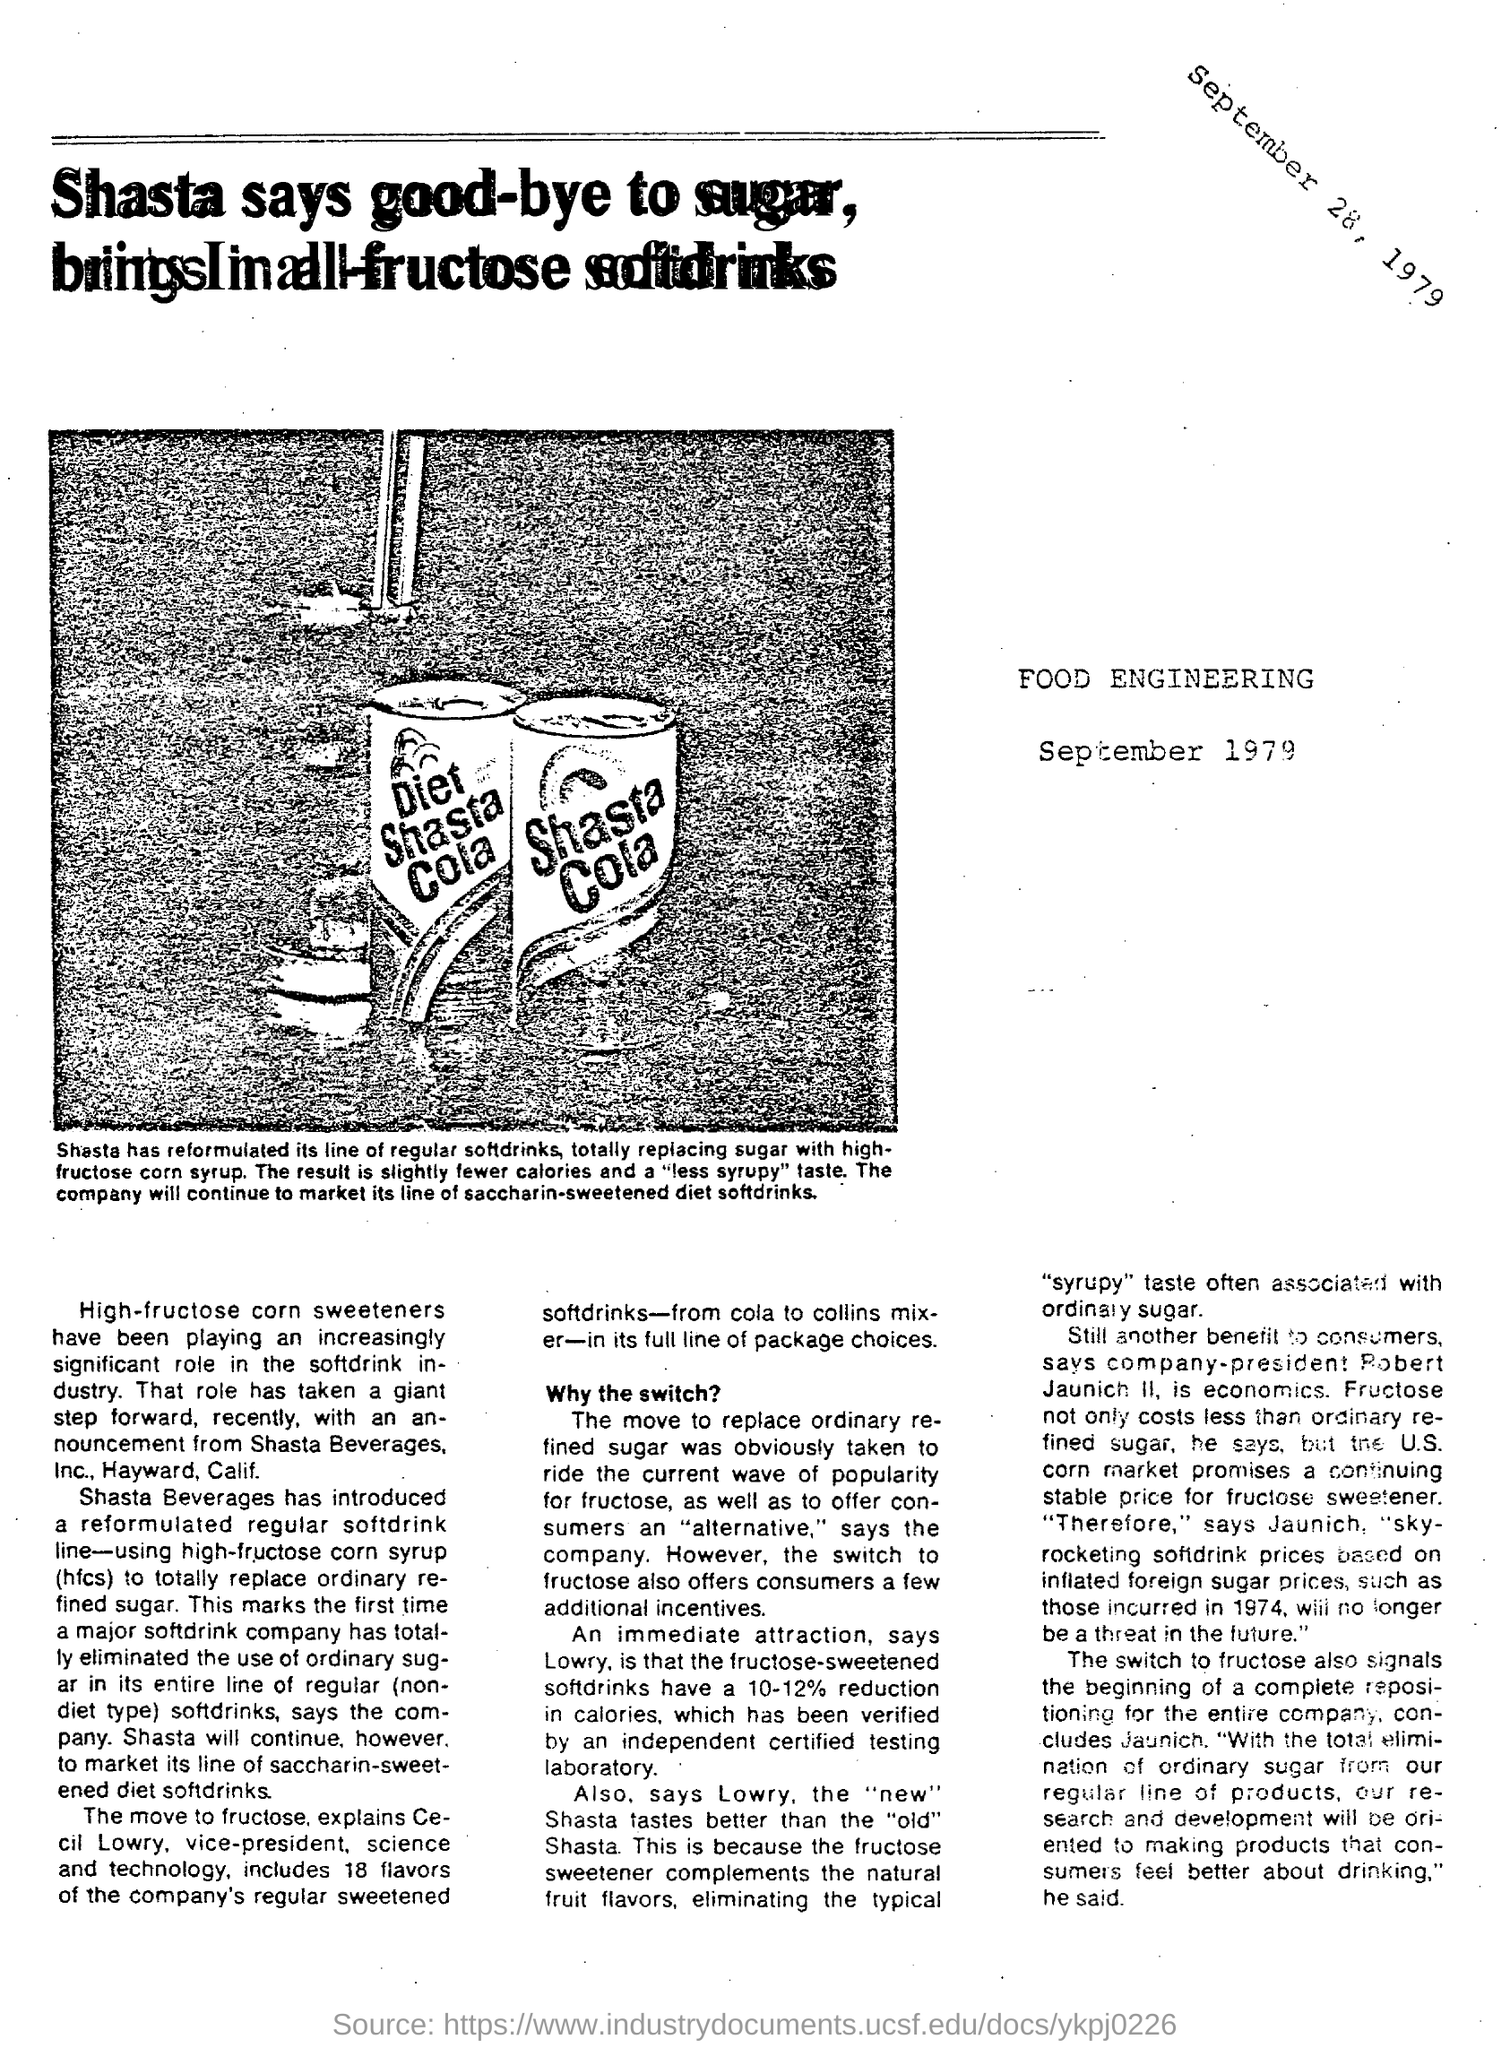Indicate a few pertinent items in this graphic. High fructose corn syrup has played a significant role in the soft drink industry. A 10-12% reduction in calories occurs in fructose-sweetened soft drinks. 